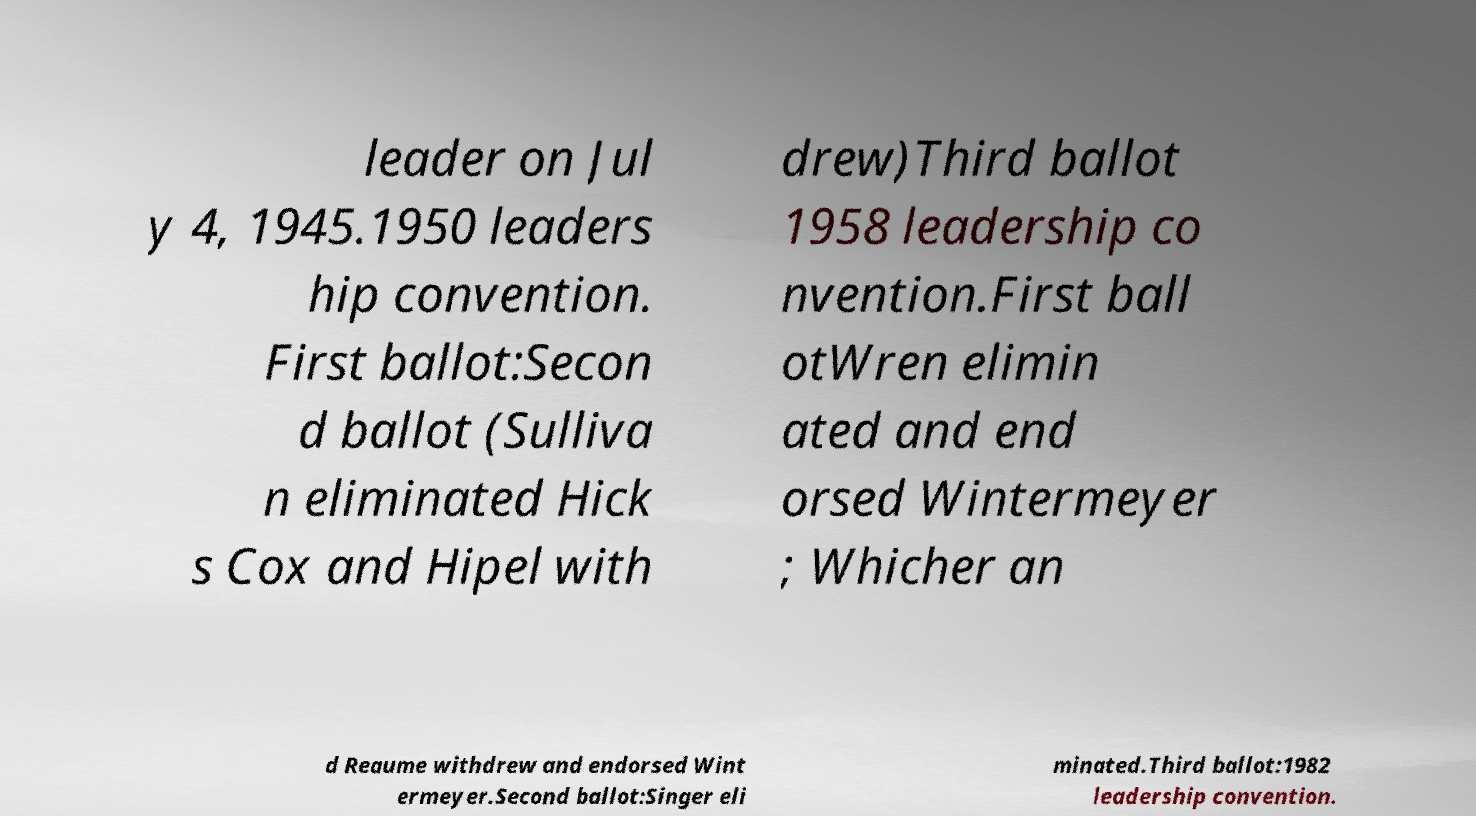I need the written content from this picture converted into text. Can you do that? leader on Jul y 4, 1945.1950 leaders hip convention. First ballot:Secon d ballot (Sulliva n eliminated Hick s Cox and Hipel with drew)Third ballot 1958 leadership co nvention.First ball otWren elimin ated and end orsed Wintermeyer ; Whicher an d Reaume withdrew and endorsed Wint ermeyer.Second ballot:Singer eli minated.Third ballot:1982 leadership convention. 